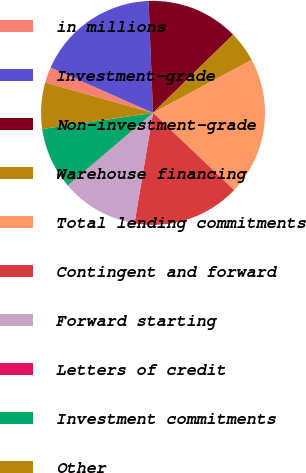Convert chart. <chart><loc_0><loc_0><loc_500><loc_500><pie_chart><fcel>in millions<fcel>Investment-grade<fcel>Non-investment-grade<fcel>Warehouse financing<fcel>Total lending commitments<fcel>Contingent and forward<fcel>Forward starting<fcel>Letters of credit<fcel>Investment commitments<fcel>Other<nl><fcel>2.26%<fcel>17.74%<fcel>13.32%<fcel>4.47%<fcel>19.96%<fcel>15.53%<fcel>11.11%<fcel>0.04%<fcel>8.89%<fcel>6.68%<nl></chart> 